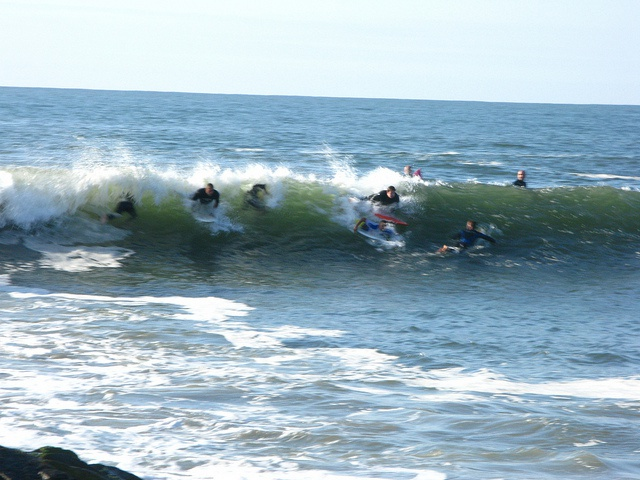Describe the objects in this image and their specific colors. I can see people in white, black, navy, gray, and blue tones, people in white, gray, teal, black, and darkgreen tones, people in white, gray, blue, and navy tones, people in white, black, gray, darkgray, and purple tones, and surfboard in white, blue, and gray tones in this image. 